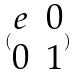<formula> <loc_0><loc_0><loc_500><loc_500>( \begin{matrix} e & 0 \\ 0 & 1 \end{matrix} )</formula> 